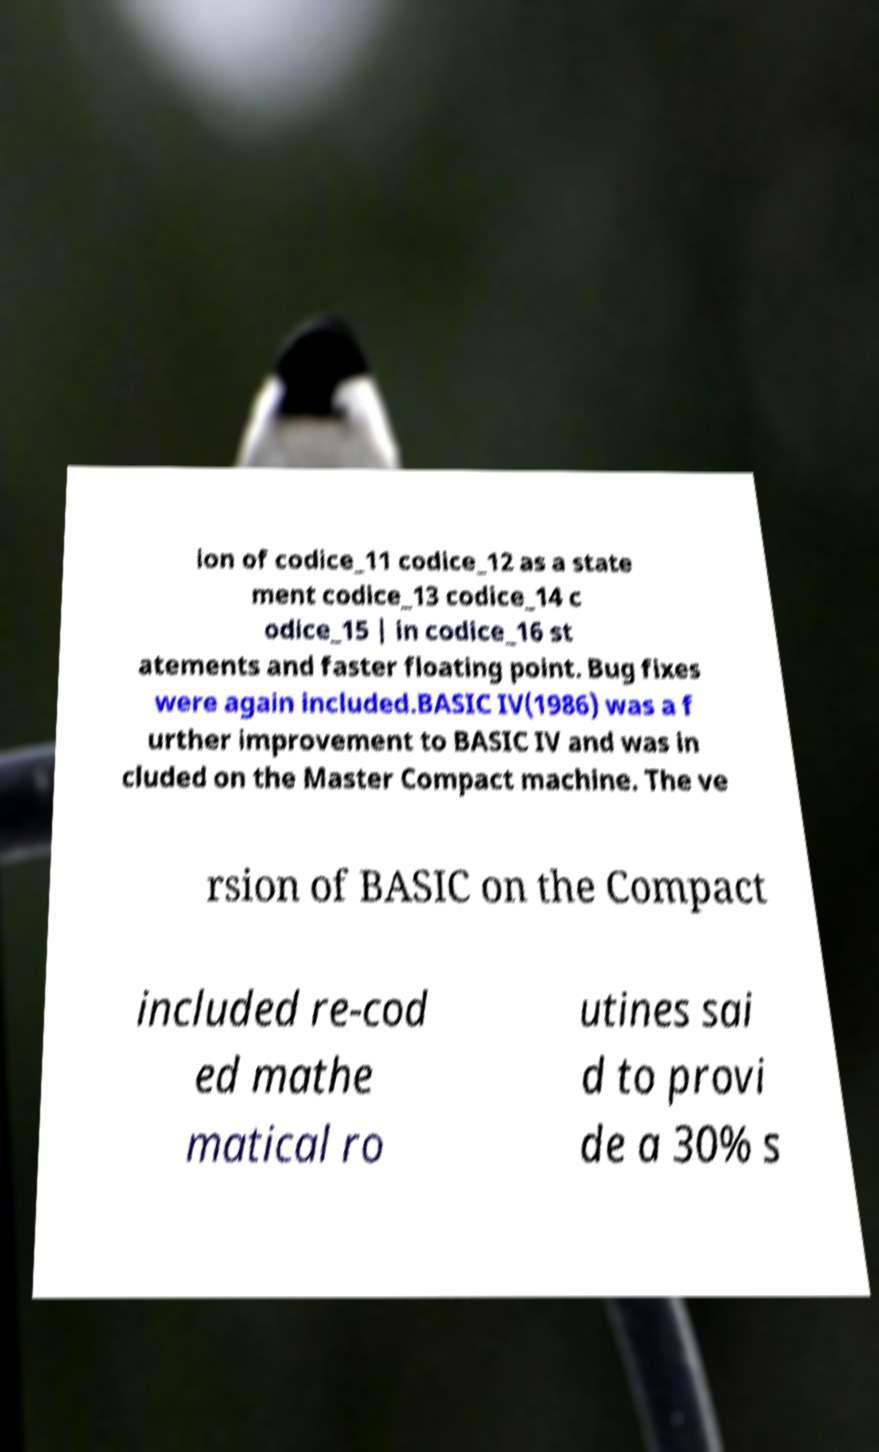Can you read and provide the text displayed in the image?This photo seems to have some interesting text. Can you extract and type it out for me? ion of codice_11 codice_12 as a state ment codice_13 codice_14 c odice_15 | in codice_16 st atements and faster floating point. Bug fixes were again included.BASIC IV(1986) was a f urther improvement to BASIC IV and was in cluded on the Master Compact machine. The ve rsion of BASIC on the Compact included re-cod ed mathe matical ro utines sai d to provi de a 30% s 